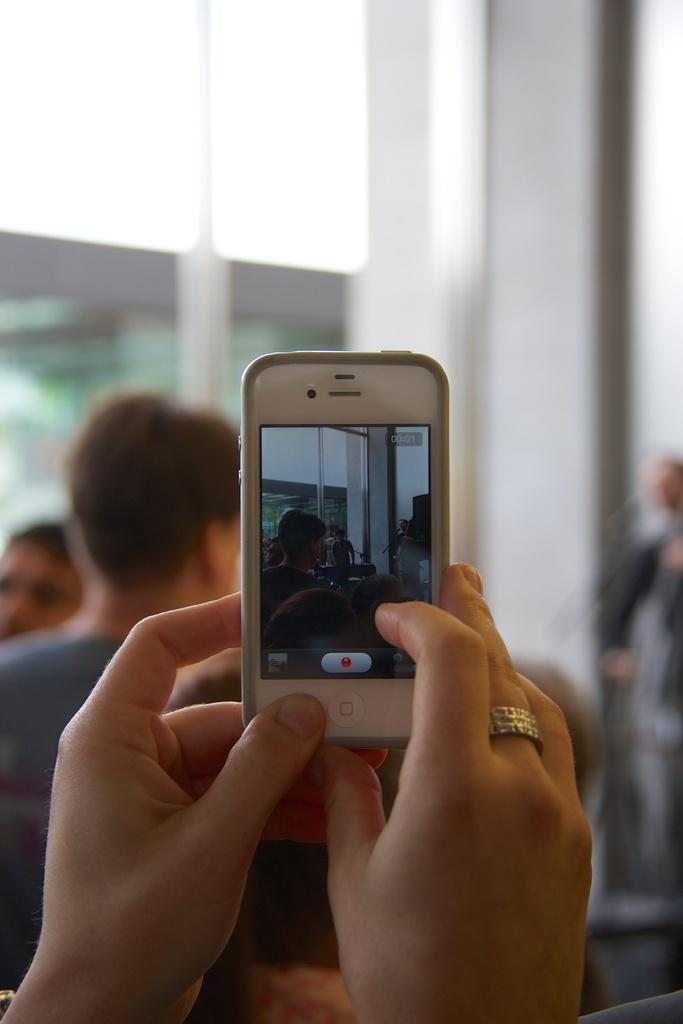What is the person in the image doing with the mobile? The person is holding a mobile and taking a picture. Who are the people in front of the person taking the picture? There are people seated in front of the person taking the picture. What type of division is being discussed by the people in the image? There is no indication of a division being discussed in the image; the focus is on the person taking a picture. 